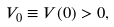Convert formula to latex. <formula><loc_0><loc_0><loc_500><loc_500>V _ { 0 } \equiv V ( 0 ) > 0 ,</formula> 